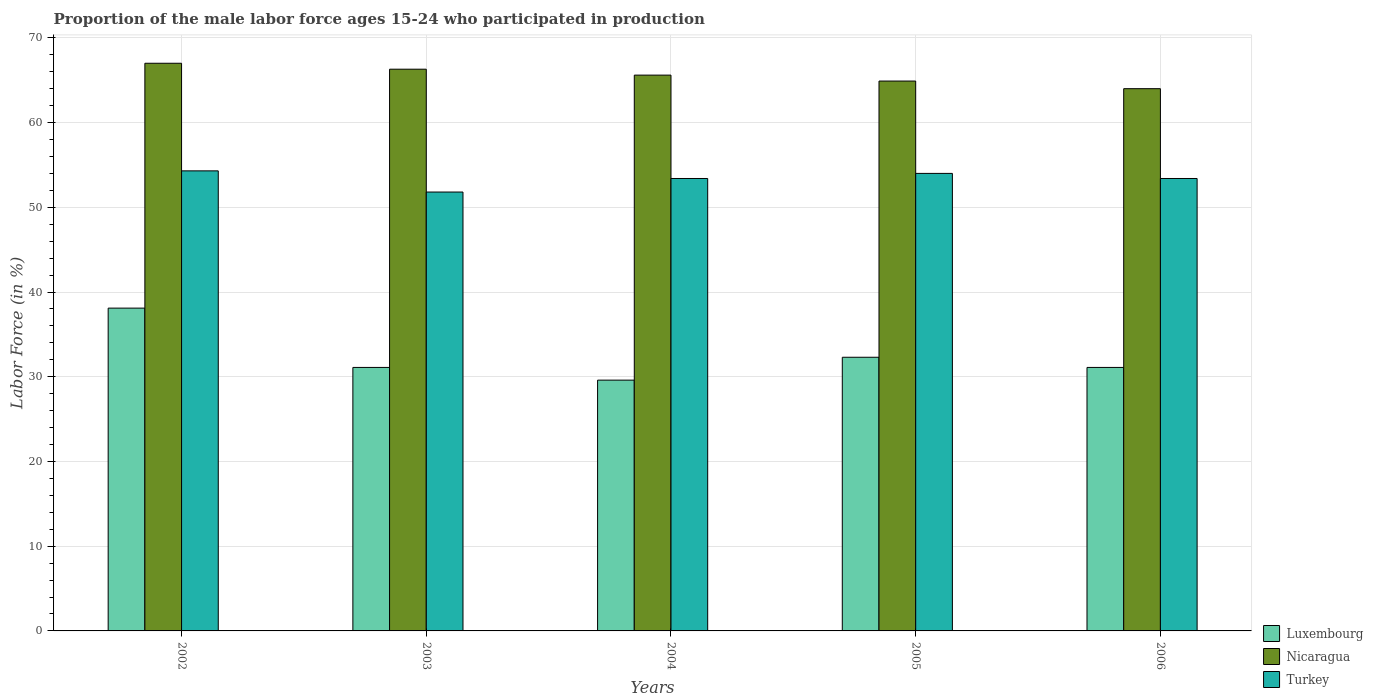How many different coloured bars are there?
Make the answer very short. 3. Are the number of bars per tick equal to the number of legend labels?
Ensure brevity in your answer.  Yes. What is the label of the 5th group of bars from the left?
Ensure brevity in your answer.  2006. In how many cases, is the number of bars for a given year not equal to the number of legend labels?
Make the answer very short. 0. What is the proportion of the male labor force who participated in production in Turkey in 2006?
Ensure brevity in your answer.  53.4. Across all years, what is the maximum proportion of the male labor force who participated in production in Turkey?
Ensure brevity in your answer.  54.3. Across all years, what is the minimum proportion of the male labor force who participated in production in Turkey?
Provide a succinct answer. 51.8. In which year was the proportion of the male labor force who participated in production in Luxembourg maximum?
Make the answer very short. 2002. In which year was the proportion of the male labor force who participated in production in Nicaragua minimum?
Offer a very short reply. 2006. What is the total proportion of the male labor force who participated in production in Nicaragua in the graph?
Ensure brevity in your answer.  327.8. What is the difference between the proportion of the male labor force who participated in production in Luxembourg in 2004 and that in 2005?
Give a very brief answer. -2.7. What is the difference between the proportion of the male labor force who participated in production in Turkey in 2005 and the proportion of the male labor force who participated in production in Luxembourg in 2004?
Keep it short and to the point. 24.4. What is the average proportion of the male labor force who participated in production in Luxembourg per year?
Keep it short and to the point. 32.44. In the year 2006, what is the difference between the proportion of the male labor force who participated in production in Nicaragua and proportion of the male labor force who participated in production in Turkey?
Give a very brief answer. 10.6. In how many years, is the proportion of the male labor force who participated in production in Turkey greater than 66 %?
Provide a succinct answer. 0. What is the ratio of the proportion of the male labor force who participated in production in Turkey in 2002 to that in 2003?
Keep it short and to the point. 1.05. Is the proportion of the male labor force who participated in production in Nicaragua in 2004 less than that in 2006?
Provide a short and direct response. No. Is the difference between the proportion of the male labor force who participated in production in Nicaragua in 2002 and 2005 greater than the difference between the proportion of the male labor force who participated in production in Turkey in 2002 and 2005?
Keep it short and to the point. Yes. What is the difference between the highest and the second highest proportion of the male labor force who participated in production in Turkey?
Provide a succinct answer. 0.3. What is the difference between the highest and the lowest proportion of the male labor force who participated in production in Luxembourg?
Provide a succinct answer. 8.5. Is the sum of the proportion of the male labor force who participated in production in Luxembourg in 2002 and 2005 greater than the maximum proportion of the male labor force who participated in production in Nicaragua across all years?
Offer a very short reply. Yes. What does the 2nd bar from the right in 2002 represents?
Your response must be concise. Nicaragua. Is it the case that in every year, the sum of the proportion of the male labor force who participated in production in Luxembourg and proportion of the male labor force who participated in production in Turkey is greater than the proportion of the male labor force who participated in production in Nicaragua?
Keep it short and to the point. Yes. Are the values on the major ticks of Y-axis written in scientific E-notation?
Offer a very short reply. No. Does the graph contain grids?
Provide a succinct answer. Yes. Where does the legend appear in the graph?
Offer a very short reply. Bottom right. How many legend labels are there?
Offer a very short reply. 3. What is the title of the graph?
Provide a short and direct response. Proportion of the male labor force ages 15-24 who participated in production. Does "Uganda" appear as one of the legend labels in the graph?
Give a very brief answer. No. What is the label or title of the X-axis?
Your answer should be compact. Years. What is the Labor Force (in %) of Luxembourg in 2002?
Your answer should be compact. 38.1. What is the Labor Force (in %) of Nicaragua in 2002?
Your answer should be very brief. 67. What is the Labor Force (in %) of Turkey in 2002?
Keep it short and to the point. 54.3. What is the Labor Force (in %) of Luxembourg in 2003?
Your answer should be compact. 31.1. What is the Labor Force (in %) in Nicaragua in 2003?
Give a very brief answer. 66.3. What is the Labor Force (in %) in Turkey in 2003?
Offer a very short reply. 51.8. What is the Labor Force (in %) of Luxembourg in 2004?
Your answer should be very brief. 29.6. What is the Labor Force (in %) of Nicaragua in 2004?
Provide a short and direct response. 65.6. What is the Labor Force (in %) of Turkey in 2004?
Offer a very short reply. 53.4. What is the Labor Force (in %) in Luxembourg in 2005?
Provide a short and direct response. 32.3. What is the Labor Force (in %) of Nicaragua in 2005?
Provide a short and direct response. 64.9. What is the Labor Force (in %) in Turkey in 2005?
Keep it short and to the point. 54. What is the Labor Force (in %) in Luxembourg in 2006?
Provide a short and direct response. 31.1. What is the Labor Force (in %) of Turkey in 2006?
Ensure brevity in your answer.  53.4. Across all years, what is the maximum Labor Force (in %) in Luxembourg?
Offer a very short reply. 38.1. Across all years, what is the maximum Labor Force (in %) of Nicaragua?
Offer a very short reply. 67. Across all years, what is the maximum Labor Force (in %) of Turkey?
Keep it short and to the point. 54.3. Across all years, what is the minimum Labor Force (in %) of Luxembourg?
Ensure brevity in your answer.  29.6. Across all years, what is the minimum Labor Force (in %) of Nicaragua?
Provide a short and direct response. 64. Across all years, what is the minimum Labor Force (in %) of Turkey?
Make the answer very short. 51.8. What is the total Labor Force (in %) of Luxembourg in the graph?
Your response must be concise. 162.2. What is the total Labor Force (in %) of Nicaragua in the graph?
Provide a succinct answer. 327.8. What is the total Labor Force (in %) in Turkey in the graph?
Make the answer very short. 266.9. What is the difference between the Labor Force (in %) in Luxembourg in 2002 and that in 2003?
Provide a short and direct response. 7. What is the difference between the Labor Force (in %) of Luxembourg in 2002 and that in 2004?
Your answer should be compact. 8.5. What is the difference between the Labor Force (in %) of Turkey in 2002 and that in 2004?
Offer a very short reply. 0.9. What is the difference between the Labor Force (in %) of Nicaragua in 2002 and that in 2005?
Offer a terse response. 2.1. What is the difference between the Labor Force (in %) in Luxembourg in 2002 and that in 2006?
Ensure brevity in your answer.  7. What is the difference between the Labor Force (in %) in Turkey in 2002 and that in 2006?
Ensure brevity in your answer.  0.9. What is the difference between the Labor Force (in %) of Nicaragua in 2003 and that in 2004?
Give a very brief answer. 0.7. What is the difference between the Labor Force (in %) of Luxembourg in 2003 and that in 2006?
Your answer should be compact. 0. What is the difference between the Labor Force (in %) in Luxembourg in 2005 and that in 2006?
Provide a succinct answer. 1.2. What is the difference between the Labor Force (in %) in Turkey in 2005 and that in 2006?
Make the answer very short. 0.6. What is the difference between the Labor Force (in %) in Luxembourg in 2002 and the Labor Force (in %) in Nicaragua in 2003?
Offer a terse response. -28.2. What is the difference between the Labor Force (in %) in Luxembourg in 2002 and the Labor Force (in %) in Turkey in 2003?
Ensure brevity in your answer.  -13.7. What is the difference between the Labor Force (in %) in Luxembourg in 2002 and the Labor Force (in %) in Nicaragua in 2004?
Give a very brief answer. -27.5. What is the difference between the Labor Force (in %) of Luxembourg in 2002 and the Labor Force (in %) of Turkey in 2004?
Offer a terse response. -15.3. What is the difference between the Labor Force (in %) of Nicaragua in 2002 and the Labor Force (in %) of Turkey in 2004?
Your answer should be very brief. 13.6. What is the difference between the Labor Force (in %) in Luxembourg in 2002 and the Labor Force (in %) in Nicaragua in 2005?
Keep it short and to the point. -26.8. What is the difference between the Labor Force (in %) of Luxembourg in 2002 and the Labor Force (in %) of Turkey in 2005?
Offer a terse response. -15.9. What is the difference between the Labor Force (in %) of Luxembourg in 2002 and the Labor Force (in %) of Nicaragua in 2006?
Keep it short and to the point. -25.9. What is the difference between the Labor Force (in %) of Luxembourg in 2002 and the Labor Force (in %) of Turkey in 2006?
Your response must be concise. -15.3. What is the difference between the Labor Force (in %) of Nicaragua in 2002 and the Labor Force (in %) of Turkey in 2006?
Provide a short and direct response. 13.6. What is the difference between the Labor Force (in %) of Luxembourg in 2003 and the Labor Force (in %) of Nicaragua in 2004?
Your answer should be compact. -34.5. What is the difference between the Labor Force (in %) in Luxembourg in 2003 and the Labor Force (in %) in Turkey in 2004?
Offer a very short reply. -22.3. What is the difference between the Labor Force (in %) of Luxembourg in 2003 and the Labor Force (in %) of Nicaragua in 2005?
Make the answer very short. -33.8. What is the difference between the Labor Force (in %) of Luxembourg in 2003 and the Labor Force (in %) of Turkey in 2005?
Your response must be concise. -22.9. What is the difference between the Labor Force (in %) in Nicaragua in 2003 and the Labor Force (in %) in Turkey in 2005?
Provide a succinct answer. 12.3. What is the difference between the Labor Force (in %) of Luxembourg in 2003 and the Labor Force (in %) of Nicaragua in 2006?
Provide a short and direct response. -32.9. What is the difference between the Labor Force (in %) in Luxembourg in 2003 and the Labor Force (in %) in Turkey in 2006?
Offer a terse response. -22.3. What is the difference between the Labor Force (in %) in Luxembourg in 2004 and the Labor Force (in %) in Nicaragua in 2005?
Ensure brevity in your answer.  -35.3. What is the difference between the Labor Force (in %) in Luxembourg in 2004 and the Labor Force (in %) in Turkey in 2005?
Give a very brief answer. -24.4. What is the difference between the Labor Force (in %) of Nicaragua in 2004 and the Labor Force (in %) of Turkey in 2005?
Your answer should be compact. 11.6. What is the difference between the Labor Force (in %) in Luxembourg in 2004 and the Labor Force (in %) in Nicaragua in 2006?
Offer a terse response. -34.4. What is the difference between the Labor Force (in %) in Luxembourg in 2004 and the Labor Force (in %) in Turkey in 2006?
Your response must be concise. -23.8. What is the difference between the Labor Force (in %) in Nicaragua in 2004 and the Labor Force (in %) in Turkey in 2006?
Your response must be concise. 12.2. What is the difference between the Labor Force (in %) of Luxembourg in 2005 and the Labor Force (in %) of Nicaragua in 2006?
Ensure brevity in your answer.  -31.7. What is the difference between the Labor Force (in %) of Luxembourg in 2005 and the Labor Force (in %) of Turkey in 2006?
Make the answer very short. -21.1. What is the difference between the Labor Force (in %) in Nicaragua in 2005 and the Labor Force (in %) in Turkey in 2006?
Your answer should be compact. 11.5. What is the average Labor Force (in %) of Luxembourg per year?
Provide a succinct answer. 32.44. What is the average Labor Force (in %) in Nicaragua per year?
Keep it short and to the point. 65.56. What is the average Labor Force (in %) of Turkey per year?
Your answer should be compact. 53.38. In the year 2002, what is the difference between the Labor Force (in %) in Luxembourg and Labor Force (in %) in Nicaragua?
Offer a terse response. -28.9. In the year 2002, what is the difference between the Labor Force (in %) of Luxembourg and Labor Force (in %) of Turkey?
Ensure brevity in your answer.  -16.2. In the year 2003, what is the difference between the Labor Force (in %) in Luxembourg and Labor Force (in %) in Nicaragua?
Offer a very short reply. -35.2. In the year 2003, what is the difference between the Labor Force (in %) of Luxembourg and Labor Force (in %) of Turkey?
Give a very brief answer. -20.7. In the year 2003, what is the difference between the Labor Force (in %) in Nicaragua and Labor Force (in %) in Turkey?
Provide a short and direct response. 14.5. In the year 2004, what is the difference between the Labor Force (in %) in Luxembourg and Labor Force (in %) in Nicaragua?
Make the answer very short. -36. In the year 2004, what is the difference between the Labor Force (in %) in Luxembourg and Labor Force (in %) in Turkey?
Provide a short and direct response. -23.8. In the year 2005, what is the difference between the Labor Force (in %) of Luxembourg and Labor Force (in %) of Nicaragua?
Ensure brevity in your answer.  -32.6. In the year 2005, what is the difference between the Labor Force (in %) in Luxembourg and Labor Force (in %) in Turkey?
Ensure brevity in your answer.  -21.7. In the year 2005, what is the difference between the Labor Force (in %) of Nicaragua and Labor Force (in %) of Turkey?
Offer a terse response. 10.9. In the year 2006, what is the difference between the Labor Force (in %) in Luxembourg and Labor Force (in %) in Nicaragua?
Make the answer very short. -32.9. In the year 2006, what is the difference between the Labor Force (in %) in Luxembourg and Labor Force (in %) in Turkey?
Provide a short and direct response. -22.3. What is the ratio of the Labor Force (in %) of Luxembourg in 2002 to that in 2003?
Keep it short and to the point. 1.23. What is the ratio of the Labor Force (in %) of Nicaragua in 2002 to that in 2003?
Provide a succinct answer. 1.01. What is the ratio of the Labor Force (in %) in Turkey in 2002 to that in 2003?
Your answer should be very brief. 1.05. What is the ratio of the Labor Force (in %) in Luxembourg in 2002 to that in 2004?
Ensure brevity in your answer.  1.29. What is the ratio of the Labor Force (in %) in Nicaragua in 2002 to that in 2004?
Provide a succinct answer. 1.02. What is the ratio of the Labor Force (in %) in Turkey in 2002 to that in 2004?
Make the answer very short. 1.02. What is the ratio of the Labor Force (in %) of Luxembourg in 2002 to that in 2005?
Make the answer very short. 1.18. What is the ratio of the Labor Force (in %) of Nicaragua in 2002 to that in 2005?
Offer a terse response. 1.03. What is the ratio of the Labor Force (in %) of Turkey in 2002 to that in 2005?
Provide a succinct answer. 1.01. What is the ratio of the Labor Force (in %) in Luxembourg in 2002 to that in 2006?
Your answer should be compact. 1.23. What is the ratio of the Labor Force (in %) of Nicaragua in 2002 to that in 2006?
Your answer should be compact. 1.05. What is the ratio of the Labor Force (in %) in Turkey in 2002 to that in 2006?
Your answer should be very brief. 1.02. What is the ratio of the Labor Force (in %) in Luxembourg in 2003 to that in 2004?
Offer a terse response. 1.05. What is the ratio of the Labor Force (in %) of Nicaragua in 2003 to that in 2004?
Give a very brief answer. 1.01. What is the ratio of the Labor Force (in %) in Luxembourg in 2003 to that in 2005?
Ensure brevity in your answer.  0.96. What is the ratio of the Labor Force (in %) of Nicaragua in 2003 to that in 2005?
Your answer should be compact. 1.02. What is the ratio of the Labor Force (in %) of Turkey in 2003 to that in 2005?
Keep it short and to the point. 0.96. What is the ratio of the Labor Force (in %) of Nicaragua in 2003 to that in 2006?
Make the answer very short. 1.04. What is the ratio of the Labor Force (in %) of Luxembourg in 2004 to that in 2005?
Your answer should be very brief. 0.92. What is the ratio of the Labor Force (in %) of Nicaragua in 2004 to that in 2005?
Provide a short and direct response. 1.01. What is the ratio of the Labor Force (in %) of Turkey in 2004 to that in 2005?
Offer a very short reply. 0.99. What is the ratio of the Labor Force (in %) in Luxembourg in 2004 to that in 2006?
Your answer should be compact. 0.95. What is the ratio of the Labor Force (in %) in Luxembourg in 2005 to that in 2006?
Provide a short and direct response. 1.04. What is the ratio of the Labor Force (in %) in Nicaragua in 2005 to that in 2006?
Provide a short and direct response. 1.01. What is the ratio of the Labor Force (in %) in Turkey in 2005 to that in 2006?
Your response must be concise. 1.01. What is the difference between the highest and the second highest Labor Force (in %) of Turkey?
Offer a very short reply. 0.3. What is the difference between the highest and the lowest Labor Force (in %) in Turkey?
Keep it short and to the point. 2.5. 